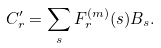Convert formula to latex. <formula><loc_0><loc_0><loc_500><loc_500>C ^ { \prime } _ { r } = \sum _ { s } F ^ { ( m ) } _ { r } ( s ) B _ { s } .</formula> 